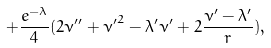<formula> <loc_0><loc_0><loc_500><loc_500>+ \frac { e ^ { - \lambda } } { 4 } ( 2 \nu ^ { \prime \prime } + { \nu ^ { \prime } } ^ { 2 } - \lambda ^ { \prime } \nu ^ { \prime } + 2 \frac { \nu ^ { \prime } - \lambda ^ { \prime } } { r } ) ,</formula> 